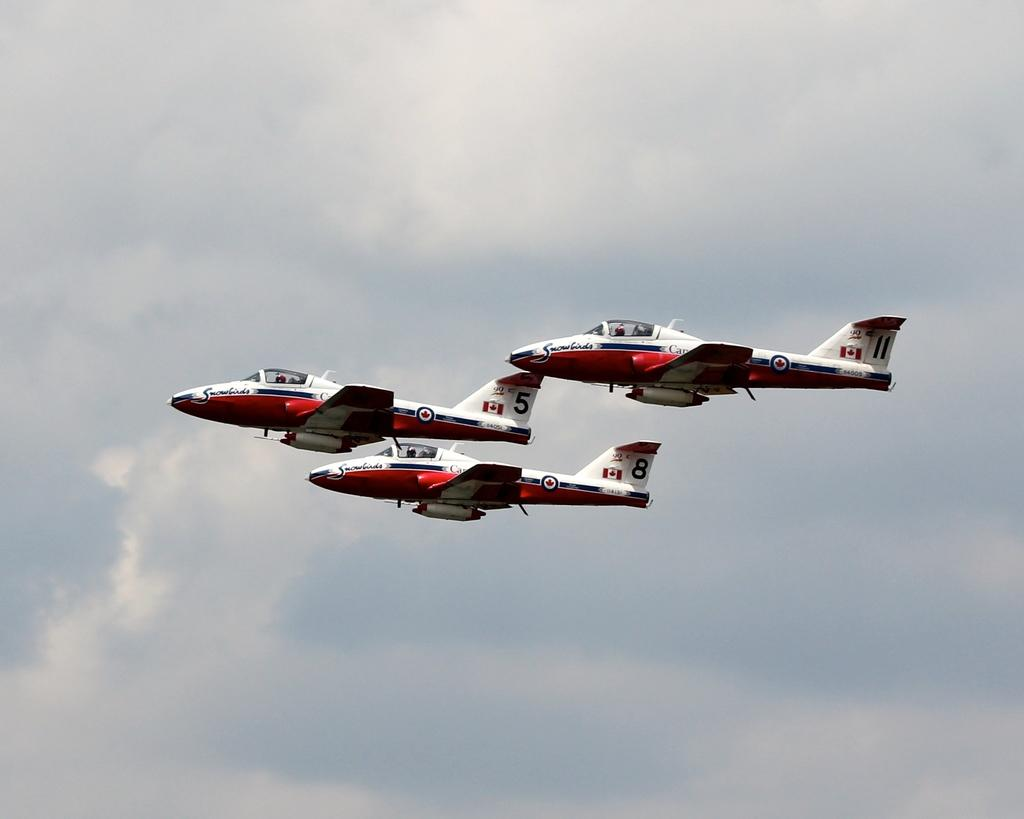How many aircrafts can be seen in the image? There are three aircrafts in the image. What are the aircrafts doing in the image? The aircrafts are flying in the sky. What type of amusement can be seen in the image? There is no amusement present in the image; it features three aircrafts flying in the sky. What kind of bait is being used by the aircrafts in the image? There is no bait present in the image; it features three aircrafts flying in the sky. 